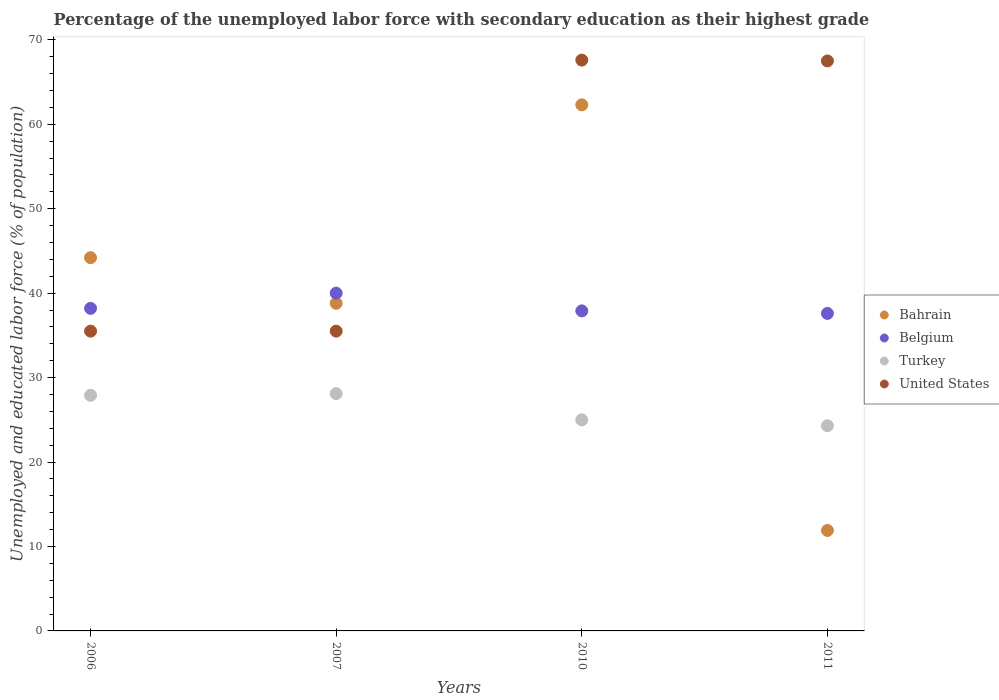How many different coloured dotlines are there?
Make the answer very short. 4. Is the number of dotlines equal to the number of legend labels?
Make the answer very short. Yes. What is the percentage of the unemployed labor force with secondary education in Belgium in 2011?
Give a very brief answer. 37.6. Across all years, what is the minimum percentage of the unemployed labor force with secondary education in Belgium?
Your response must be concise. 37.6. In which year was the percentage of the unemployed labor force with secondary education in United States minimum?
Provide a short and direct response. 2006. What is the total percentage of the unemployed labor force with secondary education in Turkey in the graph?
Provide a succinct answer. 105.3. What is the difference between the percentage of the unemployed labor force with secondary education in Bahrain in 2006 and that in 2011?
Give a very brief answer. 32.3. What is the difference between the percentage of the unemployed labor force with secondary education in United States in 2011 and the percentage of the unemployed labor force with secondary education in Belgium in 2007?
Provide a short and direct response. 27.5. What is the average percentage of the unemployed labor force with secondary education in United States per year?
Your answer should be compact. 51.52. In the year 2007, what is the difference between the percentage of the unemployed labor force with secondary education in Bahrain and percentage of the unemployed labor force with secondary education in Belgium?
Provide a succinct answer. -1.2. What is the ratio of the percentage of the unemployed labor force with secondary education in Turkey in 2007 to that in 2011?
Your answer should be compact. 1.16. What is the difference between the highest and the second highest percentage of the unemployed labor force with secondary education in Belgium?
Provide a short and direct response. 1.8. What is the difference between the highest and the lowest percentage of the unemployed labor force with secondary education in United States?
Your answer should be compact. 32.1. Is it the case that in every year, the sum of the percentage of the unemployed labor force with secondary education in Bahrain and percentage of the unemployed labor force with secondary education in Turkey  is greater than the sum of percentage of the unemployed labor force with secondary education in United States and percentage of the unemployed labor force with secondary education in Belgium?
Make the answer very short. No. Is the percentage of the unemployed labor force with secondary education in Belgium strictly greater than the percentage of the unemployed labor force with secondary education in Turkey over the years?
Your answer should be very brief. Yes. Is the percentage of the unemployed labor force with secondary education in Bahrain strictly less than the percentage of the unemployed labor force with secondary education in Belgium over the years?
Your answer should be very brief. No. How many dotlines are there?
Provide a short and direct response. 4. What is the difference between two consecutive major ticks on the Y-axis?
Your answer should be compact. 10. How many legend labels are there?
Your answer should be compact. 4. How are the legend labels stacked?
Your response must be concise. Vertical. What is the title of the graph?
Your answer should be compact. Percentage of the unemployed labor force with secondary education as their highest grade. Does "Malta" appear as one of the legend labels in the graph?
Give a very brief answer. No. What is the label or title of the X-axis?
Provide a short and direct response. Years. What is the label or title of the Y-axis?
Offer a very short reply. Unemployed and educated labor force (% of population). What is the Unemployed and educated labor force (% of population) in Bahrain in 2006?
Offer a terse response. 44.2. What is the Unemployed and educated labor force (% of population) in Belgium in 2006?
Your answer should be compact. 38.2. What is the Unemployed and educated labor force (% of population) of Turkey in 2006?
Offer a terse response. 27.9. What is the Unemployed and educated labor force (% of population) of United States in 2006?
Ensure brevity in your answer.  35.5. What is the Unemployed and educated labor force (% of population) of Bahrain in 2007?
Make the answer very short. 38.8. What is the Unemployed and educated labor force (% of population) of Belgium in 2007?
Provide a short and direct response. 40. What is the Unemployed and educated labor force (% of population) of Turkey in 2007?
Your answer should be compact. 28.1. What is the Unemployed and educated labor force (% of population) in United States in 2007?
Offer a terse response. 35.5. What is the Unemployed and educated labor force (% of population) in Bahrain in 2010?
Offer a terse response. 62.3. What is the Unemployed and educated labor force (% of population) of Belgium in 2010?
Offer a terse response. 37.9. What is the Unemployed and educated labor force (% of population) in Turkey in 2010?
Your answer should be very brief. 25. What is the Unemployed and educated labor force (% of population) in United States in 2010?
Keep it short and to the point. 67.6. What is the Unemployed and educated labor force (% of population) of Bahrain in 2011?
Your response must be concise. 11.9. What is the Unemployed and educated labor force (% of population) in Belgium in 2011?
Keep it short and to the point. 37.6. What is the Unemployed and educated labor force (% of population) in Turkey in 2011?
Keep it short and to the point. 24.3. What is the Unemployed and educated labor force (% of population) of United States in 2011?
Keep it short and to the point. 67.5. Across all years, what is the maximum Unemployed and educated labor force (% of population) in Bahrain?
Make the answer very short. 62.3. Across all years, what is the maximum Unemployed and educated labor force (% of population) of Belgium?
Your response must be concise. 40. Across all years, what is the maximum Unemployed and educated labor force (% of population) in Turkey?
Provide a succinct answer. 28.1. Across all years, what is the maximum Unemployed and educated labor force (% of population) in United States?
Provide a succinct answer. 67.6. Across all years, what is the minimum Unemployed and educated labor force (% of population) in Bahrain?
Your response must be concise. 11.9. Across all years, what is the minimum Unemployed and educated labor force (% of population) in Belgium?
Keep it short and to the point. 37.6. Across all years, what is the minimum Unemployed and educated labor force (% of population) of Turkey?
Your answer should be very brief. 24.3. Across all years, what is the minimum Unemployed and educated labor force (% of population) in United States?
Your answer should be compact. 35.5. What is the total Unemployed and educated labor force (% of population) in Bahrain in the graph?
Offer a very short reply. 157.2. What is the total Unemployed and educated labor force (% of population) in Belgium in the graph?
Provide a succinct answer. 153.7. What is the total Unemployed and educated labor force (% of population) of Turkey in the graph?
Offer a very short reply. 105.3. What is the total Unemployed and educated labor force (% of population) of United States in the graph?
Ensure brevity in your answer.  206.1. What is the difference between the Unemployed and educated labor force (% of population) in Bahrain in 2006 and that in 2007?
Offer a terse response. 5.4. What is the difference between the Unemployed and educated labor force (% of population) of Bahrain in 2006 and that in 2010?
Give a very brief answer. -18.1. What is the difference between the Unemployed and educated labor force (% of population) in Belgium in 2006 and that in 2010?
Provide a short and direct response. 0.3. What is the difference between the Unemployed and educated labor force (% of population) in Turkey in 2006 and that in 2010?
Offer a very short reply. 2.9. What is the difference between the Unemployed and educated labor force (% of population) of United States in 2006 and that in 2010?
Give a very brief answer. -32.1. What is the difference between the Unemployed and educated labor force (% of population) in Bahrain in 2006 and that in 2011?
Keep it short and to the point. 32.3. What is the difference between the Unemployed and educated labor force (% of population) of United States in 2006 and that in 2011?
Make the answer very short. -32. What is the difference between the Unemployed and educated labor force (% of population) of Bahrain in 2007 and that in 2010?
Your answer should be very brief. -23.5. What is the difference between the Unemployed and educated labor force (% of population) in Turkey in 2007 and that in 2010?
Ensure brevity in your answer.  3.1. What is the difference between the Unemployed and educated labor force (% of population) of United States in 2007 and that in 2010?
Give a very brief answer. -32.1. What is the difference between the Unemployed and educated labor force (% of population) of Bahrain in 2007 and that in 2011?
Offer a very short reply. 26.9. What is the difference between the Unemployed and educated labor force (% of population) of Belgium in 2007 and that in 2011?
Provide a short and direct response. 2.4. What is the difference between the Unemployed and educated labor force (% of population) in Turkey in 2007 and that in 2011?
Provide a short and direct response. 3.8. What is the difference between the Unemployed and educated labor force (% of population) of United States in 2007 and that in 2011?
Keep it short and to the point. -32. What is the difference between the Unemployed and educated labor force (% of population) of Bahrain in 2010 and that in 2011?
Your answer should be very brief. 50.4. What is the difference between the Unemployed and educated labor force (% of population) of Belgium in 2010 and that in 2011?
Your response must be concise. 0.3. What is the difference between the Unemployed and educated labor force (% of population) in Bahrain in 2006 and the Unemployed and educated labor force (% of population) in Belgium in 2007?
Provide a succinct answer. 4.2. What is the difference between the Unemployed and educated labor force (% of population) in Bahrain in 2006 and the Unemployed and educated labor force (% of population) in Turkey in 2007?
Make the answer very short. 16.1. What is the difference between the Unemployed and educated labor force (% of population) in Bahrain in 2006 and the Unemployed and educated labor force (% of population) in United States in 2007?
Provide a succinct answer. 8.7. What is the difference between the Unemployed and educated labor force (% of population) of Belgium in 2006 and the Unemployed and educated labor force (% of population) of Turkey in 2007?
Offer a terse response. 10.1. What is the difference between the Unemployed and educated labor force (% of population) of Belgium in 2006 and the Unemployed and educated labor force (% of population) of United States in 2007?
Give a very brief answer. 2.7. What is the difference between the Unemployed and educated labor force (% of population) of Bahrain in 2006 and the Unemployed and educated labor force (% of population) of United States in 2010?
Your response must be concise. -23.4. What is the difference between the Unemployed and educated labor force (% of population) of Belgium in 2006 and the Unemployed and educated labor force (% of population) of United States in 2010?
Provide a succinct answer. -29.4. What is the difference between the Unemployed and educated labor force (% of population) in Turkey in 2006 and the Unemployed and educated labor force (% of population) in United States in 2010?
Your response must be concise. -39.7. What is the difference between the Unemployed and educated labor force (% of population) of Bahrain in 2006 and the Unemployed and educated labor force (% of population) of Belgium in 2011?
Your answer should be very brief. 6.6. What is the difference between the Unemployed and educated labor force (% of population) of Bahrain in 2006 and the Unemployed and educated labor force (% of population) of United States in 2011?
Your answer should be compact. -23.3. What is the difference between the Unemployed and educated labor force (% of population) of Belgium in 2006 and the Unemployed and educated labor force (% of population) of United States in 2011?
Offer a terse response. -29.3. What is the difference between the Unemployed and educated labor force (% of population) in Turkey in 2006 and the Unemployed and educated labor force (% of population) in United States in 2011?
Offer a very short reply. -39.6. What is the difference between the Unemployed and educated labor force (% of population) of Bahrain in 2007 and the Unemployed and educated labor force (% of population) of Belgium in 2010?
Your response must be concise. 0.9. What is the difference between the Unemployed and educated labor force (% of population) in Bahrain in 2007 and the Unemployed and educated labor force (% of population) in Turkey in 2010?
Keep it short and to the point. 13.8. What is the difference between the Unemployed and educated labor force (% of population) in Bahrain in 2007 and the Unemployed and educated labor force (% of population) in United States in 2010?
Provide a succinct answer. -28.8. What is the difference between the Unemployed and educated labor force (% of population) in Belgium in 2007 and the Unemployed and educated labor force (% of population) in Turkey in 2010?
Offer a very short reply. 15. What is the difference between the Unemployed and educated labor force (% of population) of Belgium in 2007 and the Unemployed and educated labor force (% of population) of United States in 2010?
Provide a succinct answer. -27.6. What is the difference between the Unemployed and educated labor force (% of population) in Turkey in 2007 and the Unemployed and educated labor force (% of population) in United States in 2010?
Keep it short and to the point. -39.5. What is the difference between the Unemployed and educated labor force (% of population) of Bahrain in 2007 and the Unemployed and educated labor force (% of population) of Belgium in 2011?
Ensure brevity in your answer.  1.2. What is the difference between the Unemployed and educated labor force (% of population) in Bahrain in 2007 and the Unemployed and educated labor force (% of population) in Turkey in 2011?
Offer a terse response. 14.5. What is the difference between the Unemployed and educated labor force (% of population) of Bahrain in 2007 and the Unemployed and educated labor force (% of population) of United States in 2011?
Offer a terse response. -28.7. What is the difference between the Unemployed and educated labor force (% of population) in Belgium in 2007 and the Unemployed and educated labor force (% of population) in Turkey in 2011?
Offer a terse response. 15.7. What is the difference between the Unemployed and educated labor force (% of population) of Belgium in 2007 and the Unemployed and educated labor force (% of population) of United States in 2011?
Your answer should be compact. -27.5. What is the difference between the Unemployed and educated labor force (% of population) of Turkey in 2007 and the Unemployed and educated labor force (% of population) of United States in 2011?
Offer a terse response. -39.4. What is the difference between the Unemployed and educated labor force (% of population) of Bahrain in 2010 and the Unemployed and educated labor force (% of population) of Belgium in 2011?
Provide a short and direct response. 24.7. What is the difference between the Unemployed and educated labor force (% of population) of Bahrain in 2010 and the Unemployed and educated labor force (% of population) of Turkey in 2011?
Offer a very short reply. 38. What is the difference between the Unemployed and educated labor force (% of population) of Belgium in 2010 and the Unemployed and educated labor force (% of population) of United States in 2011?
Offer a very short reply. -29.6. What is the difference between the Unemployed and educated labor force (% of population) in Turkey in 2010 and the Unemployed and educated labor force (% of population) in United States in 2011?
Offer a very short reply. -42.5. What is the average Unemployed and educated labor force (% of population) in Bahrain per year?
Provide a short and direct response. 39.3. What is the average Unemployed and educated labor force (% of population) in Belgium per year?
Give a very brief answer. 38.42. What is the average Unemployed and educated labor force (% of population) in Turkey per year?
Provide a succinct answer. 26.32. What is the average Unemployed and educated labor force (% of population) of United States per year?
Make the answer very short. 51.52. In the year 2006, what is the difference between the Unemployed and educated labor force (% of population) in Bahrain and Unemployed and educated labor force (% of population) in Turkey?
Provide a short and direct response. 16.3. In the year 2006, what is the difference between the Unemployed and educated labor force (% of population) of Belgium and Unemployed and educated labor force (% of population) of United States?
Give a very brief answer. 2.7. In the year 2006, what is the difference between the Unemployed and educated labor force (% of population) of Turkey and Unemployed and educated labor force (% of population) of United States?
Give a very brief answer. -7.6. In the year 2007, what is the difference between the Unemployed and educated labor force (% of population) of Turkey and Unemployed and educated labor force (% of population) of United States?
Offer a very short reply. -7.4. In the year 2010, what is the difference between the Unemployed and educated labor force (% of population) of Bahrain and Unemployed and educated labor force (% of population) of Belgium?
Keep it short and to the point. 24.4. In the year 2010, what is the difference between the Unemployed and educated labor force (% of population) of Bahrain and Unemployed and educated labor force (% of population) of Turkey?
Your response must be concise. 37.3. In the year 2010, what is the difference between the Unemployed and educated labor force (% of population) of Belgium and Unemployed and educated labor force (% of population) of United States?
Offer a terse response. -29.7. In the year 2010, what is the difference between the Unemployed and educated labor force (% of population) of Turkey and Unemployed and educated labor force (% of population) of United States?
Make the answer very short. -42.6. In the year 2011, what is the difference between the Unemployed and educated labor force (% of population) in Bahrain and Unemployed and educated labor force (% of population) in Belgium?
Make the answer very short. -25.7. In the year 2011, what is the difference between the Unemployed and educated labor force (% of population) of Bahrain and Unemployed and educated labor force (% of population) of United States?
Make the answer very short. -55.6. In the year 2011, what is the difference between the Unemployed and educated labor force (% of population) of Belgium and Unemployed and educated labor force (% of population) of Turkey?
Your answer should be compact. 13.3. In the year 2011, what is the difference between the Unemployed and educated labor force (% of population) in Belgium and Unemployed and educated labor force (% of population) in United States?
Offer a very short reply. -29.9. In the year 2011, what is the difference between the Unemployed and educated labor force (% of population) in Turkey and Unemployed and educated labor force (% of population) in United States?
Make the answer very short. -43.2. What is the ratio of the Unemployed and educated labor force (% of population) of Bahrain in 2006 to that in 2007?
Give a very brief answer. 1.14. What is the ratio of the Unemployed and educated labor force (% of population) of Belgium in 2006 to that in 2007?
Your response must be concise. 0.95. What is the ratio of the Unemployed and educated labor force (% of population) of Turkey in 2006 to that in 2007?
Make the answer very short. 0.99. What is the ratio of the Unemployed and educated labor force (% of population) in Bahrain in 2006 to that in 2010?
Provide a succinct answer. 0.71. What is the ratio of the Unemployed and educated labor force (% of population) in Belgium in 2006 to that in 2010?
Your answer should be compact. 1.01. What is the ratio of the Unemployed and educated labor force (% of population) in Turkey in 2006 to that in 2010?
Your response must be concise. 1.12. What is the ratio of the Unemployed and educated labor force (% of population) of United States in 2006 to that in 2010?
Give a very brief answer. 0.53. What is the ratio of the Unemployed and educated labor force (% of population) in Bahrain in 2006 to that in 2011?
Ensure brevity in your answer.  3.71. What is the ratio of the Unemployed and educated labor force (% of population) in Belgium in 2006 to that in 2011?
Your answer should be very brief. 1.02. What is the ratio of the Unemployed and educated labor force (% of population) in Turkey in 2006 to that in 2011?
Offer a terse response. 1.15. What is the ratio of the Unemployed and educated labor force (% of population) of United States in 2006 to that in 2011?
Your response must be concise. 0.53. What is the ratio of the Unemployed and educated labor force (% of population) of Bahrain in 2007 to that in 2010?
Your answer should be compact. 0.62. What is the ratio of the Unemployed and educated labor force (% of population) of Belgium in 2007 to that in 2010?
Offer a terse response. 1.06. What is the ratio of the Unemployed and educated labor force (% of population) of Turkey in 2007 to that in 2010?
Offer a terse response. 1.12. What is the ratio of the Unemployed and educated labor force (% of population) in United States in 2007 to that in 2010?
Keep it short and to the point. 0.53. What is the ratio of the Unemployed and educated labor force (% of population) in Bahrain in 2007 to that in 2011?
Make the answer very short. 3.26. What is the ratio of the Unemployed and educated labor force (% of population) in Belgium in 2007 to that in 2011?
Your answer should be very brief. 1.06. What is the ratio of the Unemployed and educated labor force (% of population) of Turkey in 2007 to that in 2011?
Make the answer very short. 1.16. What is the ratio of the Unemployed and educated labor force (% of population) of United States in 2007 to that in 2011?
Provide a succinct answer. 0.53. What is the ratio of the Unemployed and educated labor force (% of population) in Bahrain in 2010 to that in 2011?
Keep it short and to the point. 5.24. What is the ratio of the Unemployed and educated labor force (% of population) in Turkey in 2010 to that in 2011?
Offer a very short reply. 1.03. What is the difference between the highest and the second highest Unemployed and educated labor force (% of population) in Bahrain?
Your answer should be compact. 18.1. What is the difference between the highest and the second highest Unemployed and educated labor force (% of population) in Turkey?
Offer a terse response. 0.2. What is the difference between the highest and the second highest Unemployed and educated labor force (% of population) of United States?
Provide a short and direct response. 0.1. What is the difference between the highest and the lowest Unemployed and educated labor force (% of population) of Bahrain?
Offer a terse response. 50.4. What is the difference between the highest and the lowest Unemployed and educated labor force (% of population) in United States?
Offer a very short reply. 32.1. 